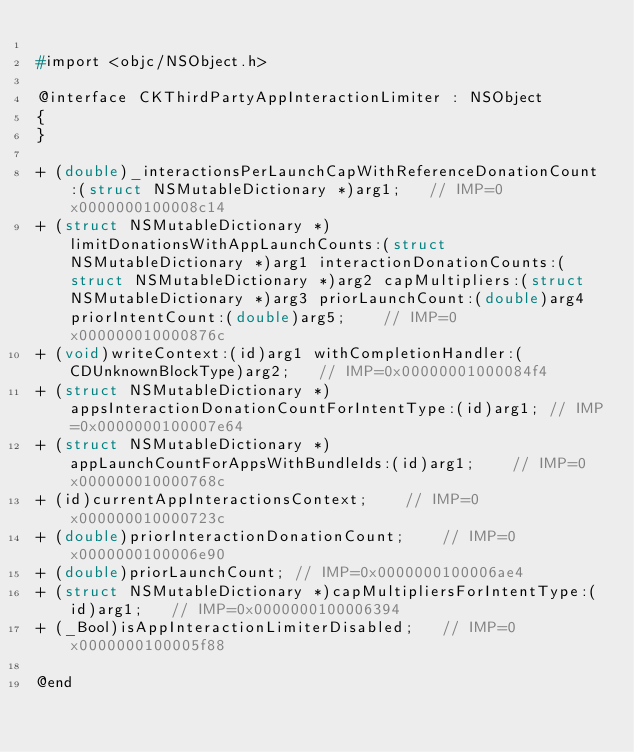Convert code to text. <code><loc_0><loc_0><loc_500><loc_500><_C_>
#import <objc/NSObject.h>

@interface CKThirdPartyAppInteractionLimiter : NSObject
{
}

+ (double)_interactionsPerLaunchCapWithReferenceDonationCount:(struct NSMutableDictionary *)arg1;	// IMP=0x0000000100008c14
+ (struct NSMutableDictionary *)limitDonationsWithAppLaunchCounts:(struct NSMutableDictionary *)arg1 interactionDonationCounts:(struct NSMutableDictionary *)arg2 capMultipliers:(struct NSMutableDictionary *)arg3 priorLaunchCount:(double)arg4 priorIntentCount:(double)arg5;	// IMP=0x000000010000876c
+ (void)writeContext:(id)arg1 withCompletionHandler:(CDUnknownBlockType)arg2;	// IMP=0x00000001000084f4
+ (struct NSMutableDictionary *)appsInteractionDonationCountForIntentType:(id)arg1;	// IMP=0x0000000100007e64
+ (struct NSMutableDictionary *)appLaunchCountForAppsWithBundleIds:(id)arg1;	// IMP=0x000000010000768c
+ (id)currentAppInteractionsContext;	// IMP=0x000000010000723c
+ (double)priorInteractionDonationCount;	// IMP=0x0000000100006e90
+ (double)priorLaunchCount;	// IMP=0x0000000100006ae4
+ (struct NSMutableDictionary *)capMultipliersForIntentType:(id)arg1;	// IMP=0x0000000100006394
+ (_Bool)isAppInteractionLimiterDisabled;	// IMP=0x0000000100005f88

@end

</code> 